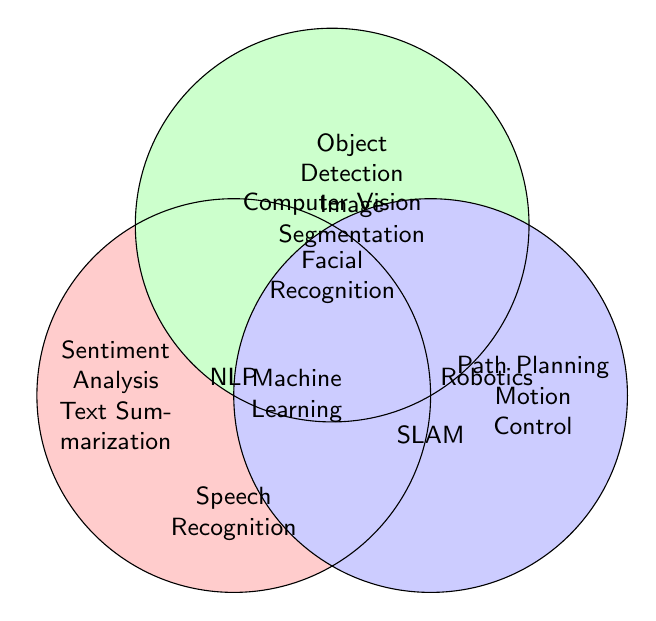What are the application areas listed only under NLP? We need to look at the segment labeled NLP that does not overlap with Computer Vision or Robotics sections. The items are: Sentiment Analysis, Text Summarization, Machine Translation, Speech Recognition, and Named Entity Recognition.
Answer: Sentiment Analysis, Text Summarization, Machine Translation, Speech Recognition, Named Entity Recognition Which areas are associated with Computer Vision but not with Robotics? We find the section labeled Computer Vision and exclude the items in overlapping areas with Robotics. These items are: Object Detection, Image Segmentation, Facial Recognition, Pose Estimation, and Optical Character Recognition.
Answer: Object Detection, Image Segmentation, Facial Recognition, Pose Estimation, Optical Character Recognition What application area(s) are common between Computer Vision and Robotics? Locate the area where the Computer Vision and Robotics circles overlap and identify the items. The item here is: SLAM.
Answer: SLAM How many application areas are there in total across all three fields? Combine all unique items from NLP, Computer Vision, and Robotics, then count them. Total unique items are: Sentiment Analysis, Text Summarization, Machine Translation, Speech Recognition, Named Entity Recognition, Object Detection, Image Segmentation, Facial Recognition, Pose Estimation, Optical Character Recognition, Path Planning, Motion Control, Obstacle Avoidance, Grasping, SLAM. There are 15 in total.
Answer: 15 Which application areas are listed under Robotics alone? Check the Robotics section exclusive of overlapping areas with NLP and Computer Vision. The items are: Path Planning, Motion Control, Obstacle Avoidance, Grasping.
Answer: Path Planning, Motion Control, Obstacle Avoidance, Grasping Is there any application area that spans all three fields (NLP, Computer Vision, Robotics)? Look at the intersection part where all three circles overlap. There is no item listed here.
Answer: No What overlaps exist between NLP and Computer Vision? Identify the area where the NLP and Computer Vision circles overlap but do not intersect with Robotics circle. The shared item in the intersection is: none. Thus, no items here.
Answer: None Which application under Robotics is related to environment mapping? In the Robotics section, find the description related to environment mapping. SLAM (Simultaneous Localization and Mapping) fits this description.
Answer: SLAM 